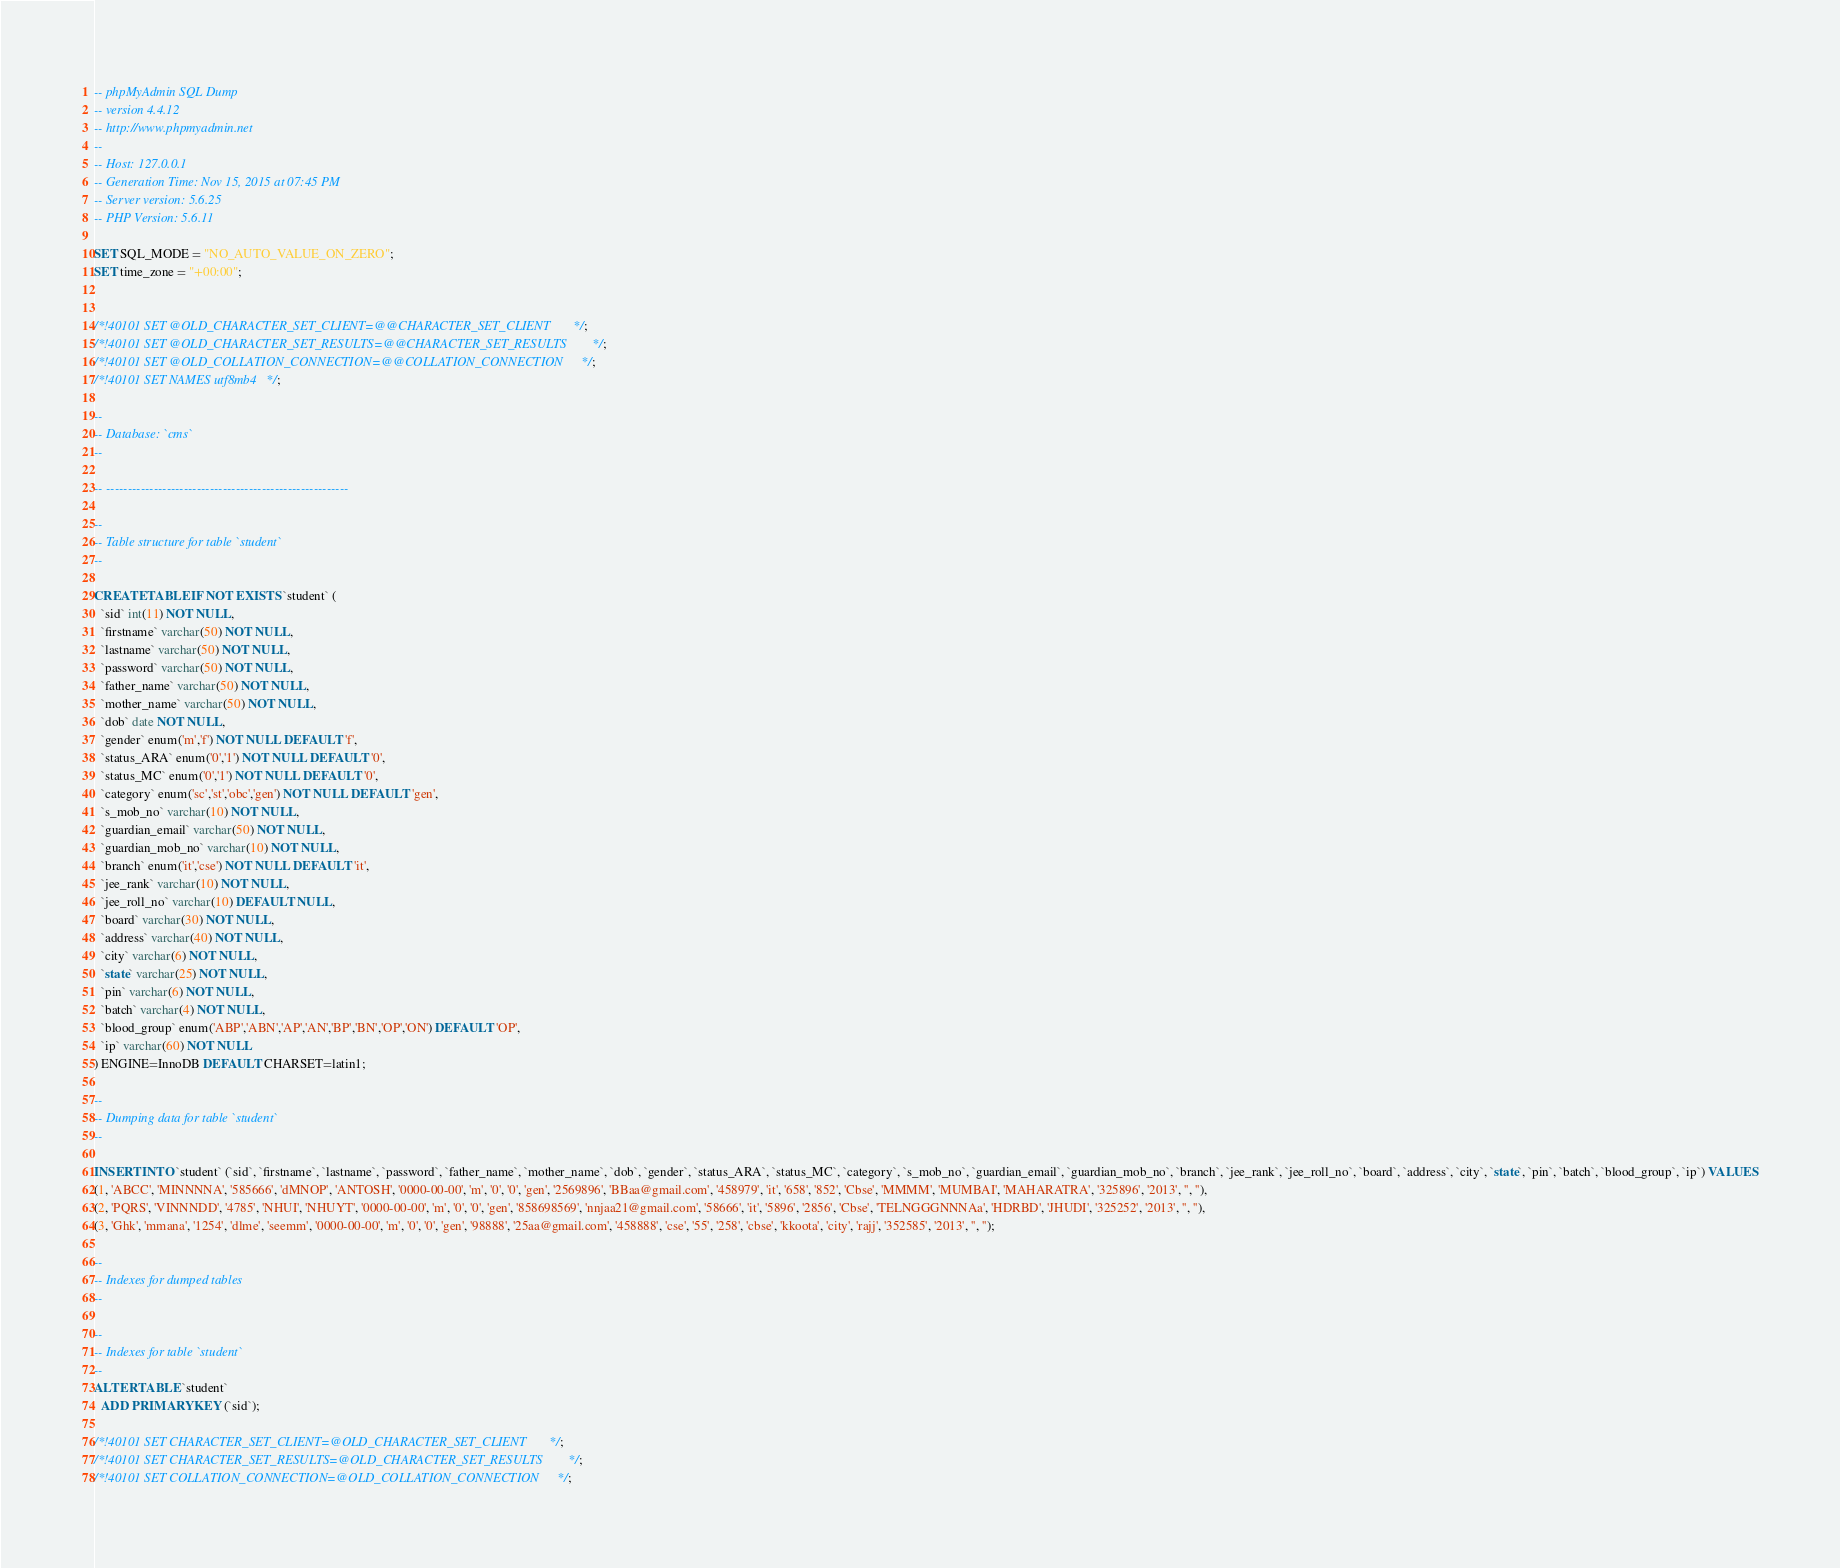<code> <loc_0><loc_0><loc_500><loc_500><_SQL_>-- phpMyAdmin SQL Dump
-- version 4.4.12
-- http://www.phpmyadmin.net
--
-- Host: 127.0.0.1
-- Generation Time: Nov 15, 2015 at 07:45 PM
-- Server version: 5.6.25
-- PHP Version: 5.6.11

SET SQL_MODE = "NO_AUTO_VALUE_ON_ZERO";
SET time_zone = "+00:00";


/*!40101 SET @OLD_CHARACTER_SET_CLIENT=@@CHARACTER_SET_CLIENT */;
/*!40101 SET @OLD_CHARACTER_SET_RESULTS=@@CHARACTER_SET_RESULTS */;
/*!40101 SET @OLD_COLLATION_CONNECTION=@@COLLATION_CONNECTION */;
/*!40101 SET NAMES utf8mb4 */;

--
-- Database: `cms`
--

-- --------------------------------------------------------

--
-- Table structure for table `student`
--

CREATE TABLE IF NOT EXISTS `student` (
  `sid` int(11) NOT NULL,
  `firstname` varchar(50) NOT NULL,
  `lastname` varchar(50) NOT NULL,
  `password` varchar(50) NOT NULL,
  `father_name` varchar(50) NOT NULL,
  `mother_name` varchar(50) NOT NULL,
  `dob` date NOT NULL,
  `gender` enum('m','f') NOT NULL DEFAULT 'f',
  `status_ARA` enum('0','1') NOT NULL DEFAULT '0',
  `status_MC` enum('0','1') NOT NULL DEFAULT '0',
  `category` enum('sc','st','obc','gen') NOT NULL DEFAULT 'gen',
  `s_mob_no` varchar(10) NOT NULL,
  `guardian_email` varchar(50) NOT NULL,
  `guardian_mob_no` varchar(10) NOT NULL,
  `branch` enum('it','cse') NOT NULL DEFAULT 'it',
  `jee_rank` varchar(10) NOT NULL,
  `jee_roll_no` varchar(10) DEFAULT NULL,
  `board` varchar(30) NOT NULL,
  `address` varchar(40) NOT NULL,
  `city` varchar(6) NOT NULL,
  `state` varchar(25) NOT NULL,
  `pin` varchar(6) NOT NULL,
  `batch` varchar(4) NOT NULL,
  `blood_group` enum('ABP','ABN','AP','AN','BP','BN','OP','ON') DEFAULT 'OP',
  `ip` varchar(60) NOT NULL
) ENGINE=InnoDB DEFAULT CHARSET=latin1;

--
-- Dumping data for table `student`
--

INSERT INTO `student` (`sid`, `firstname`, `lastname`, `password`, `father_name`, `mother_name`, `dob`, `gender`, `status_ARA`, `status_MC`, `category`, `s_mob_no`, `guardian_email`, `guardian_mob_no`, `branch`, `jee_rank`, `jee_roll_no`, `board`, `address`, `city`, `state`, `pin`, `batch`, `blood_group`, `ip`) VALUES
(1, 'ABCC', 'MINNNNA', '585666', 'dMNOP', 'ANTOSH', '0000-00-00', 'm', '0', '0', 'gen', '2569896', 'BBaa@gmail.com', '458979', 'it', '658', '852', 'Cbse', 'MMMM', 'MUMBAI', 'MAHARATRA', '325896', '2013', '', ''),
(2, 'PQRS', 'VINNNDD', '4785', 'NHUI', 'NHUYT', '0000-00-00', 'm', '0', '0', 'gen', '858698569', 'nnjaa21@gmail.com', '58666', 'it', '5896', '2856', 'Cbse', 'TELNGGGNNNAa', 'HDRBD', 'JHUDI', '325252', '2013', '', ''),
(3, 'Ghk', 'mmana', '1254', 'dlme', 'seemm', '0000-00-00', 'm', '0', '0', 'gen', '98888', '25aa@gmail.com', '458888', 'cse', '55', '258', 'cbse', 'kkoota', 'city', 'rajj', '352585', '2013', '', '');

--
-- Indexes for dumped tables
--

--
-- Indexes for table `student`
--
ALTER TABLE `student`
  ADD PRIMARY KEY (`sid`);

/*!40101 SET CHARACTER_SET_CLIENT=@OLD_CHARACTER_SET_CLIENT */;
/*!40101 SET CHARACTER_SET_RESULTS=@OLD_CHARACTER_SET_RESULTS */;
/*!40101 SET COLLATION_CONNECTION=@OLD_COLLATION_CONNECTION */;
</code> 